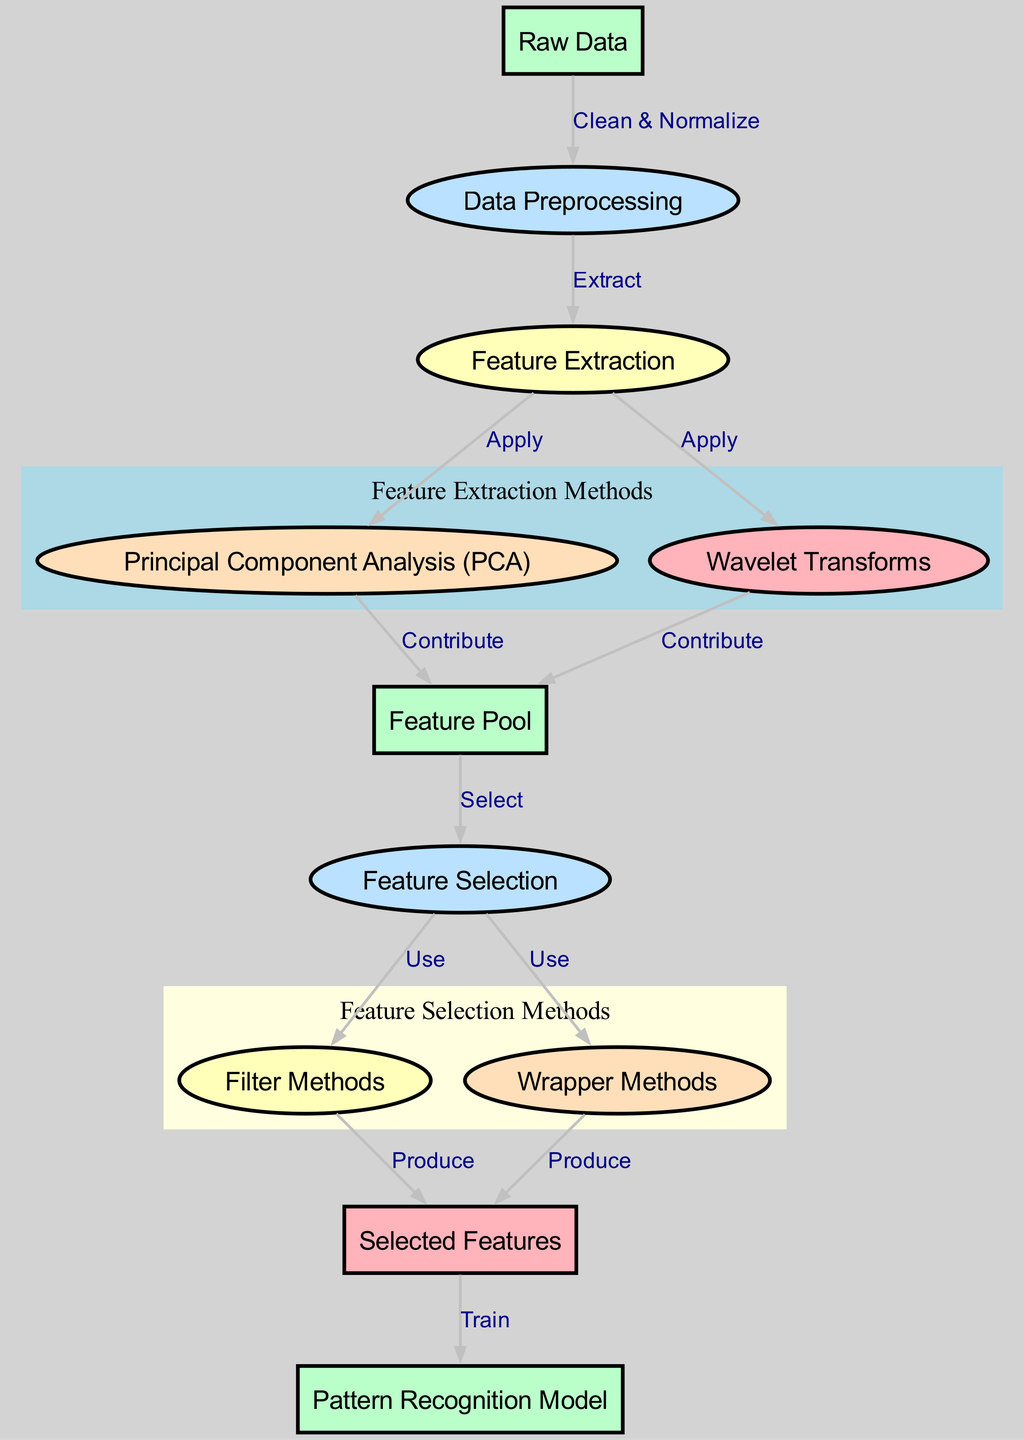What is the first step in the process? The first node in the diagram is labeled "Raw Data," indicating that this is the starting point of the feature extraction and selection process.
Answer: Raw Data How many total nodes are present in the diagram? By counting the nodes outlined in the data, there are 11 total nodes represented in the diagram.
Answer: 11 Which process directly follows Data Preprocessing? The edge labeled "Extract" leads from "Data Preprocessing" to "Feature Extraction," indicating that feature extraction is the next step.
Answer: Feature Extraction What type of methods are represented within the cluster labeled "Feature Selection Methods"? The cluster includes two nodes, "Filter Methods" and "Wrapper Methods," which are explicitly labeled as feature selection methods.
Answer: Filter Methods and Wrapper Methods How do Feature Extraction methods contribute to the Feature Pool? Both "Principal Component Analysis (PCA)" and "Wavelet Transforms" have edges leading to "Feature Pool," denoting that they contribute features to this pool as part of the extraction process.
Answer: Contribute 